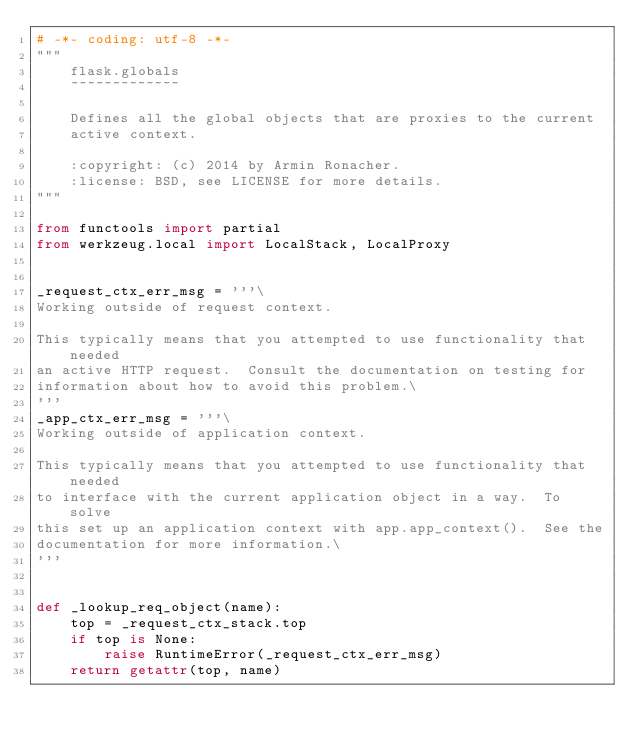Convert code to text. <code><loc_0><loc_0><loc_500><loc_500><_Python_># -*- coding: utf-8 -*-
"""
    flask.globals
    ~~~~~~~~~~~~~

    Defines all the global objects that are proxies to the current
    active context.

    :copyright: (c) 2014 by Armin Ronacher.
    :license: BSD, see LICENSE for more details.
"""

from functools import partial
from werkzeug.local import LocalStack, LocalProxy


_request_ctx_err_msg = '''\
Working outside of request context.

This typically means that you attempted to use functionality that needed
an active HTTP request.  Consult the documentation on testing for
information about how to avoid this problem.\
'''
_app_ctx_err_msg = '''\
Working outside of application context.

This typically means that you attempted to use functionality that needed
to interface with the current application object in a way.  To solve
this set up an application context with app.app_context().  See the
documentation for more information.\
'''


def _lookup_req_object(name):
    top = _request_ctx_stack.top
    if top is None:
        raise RuntimeError(_request_ctx_err_msg)
    return getattr(top, name)

</code> 